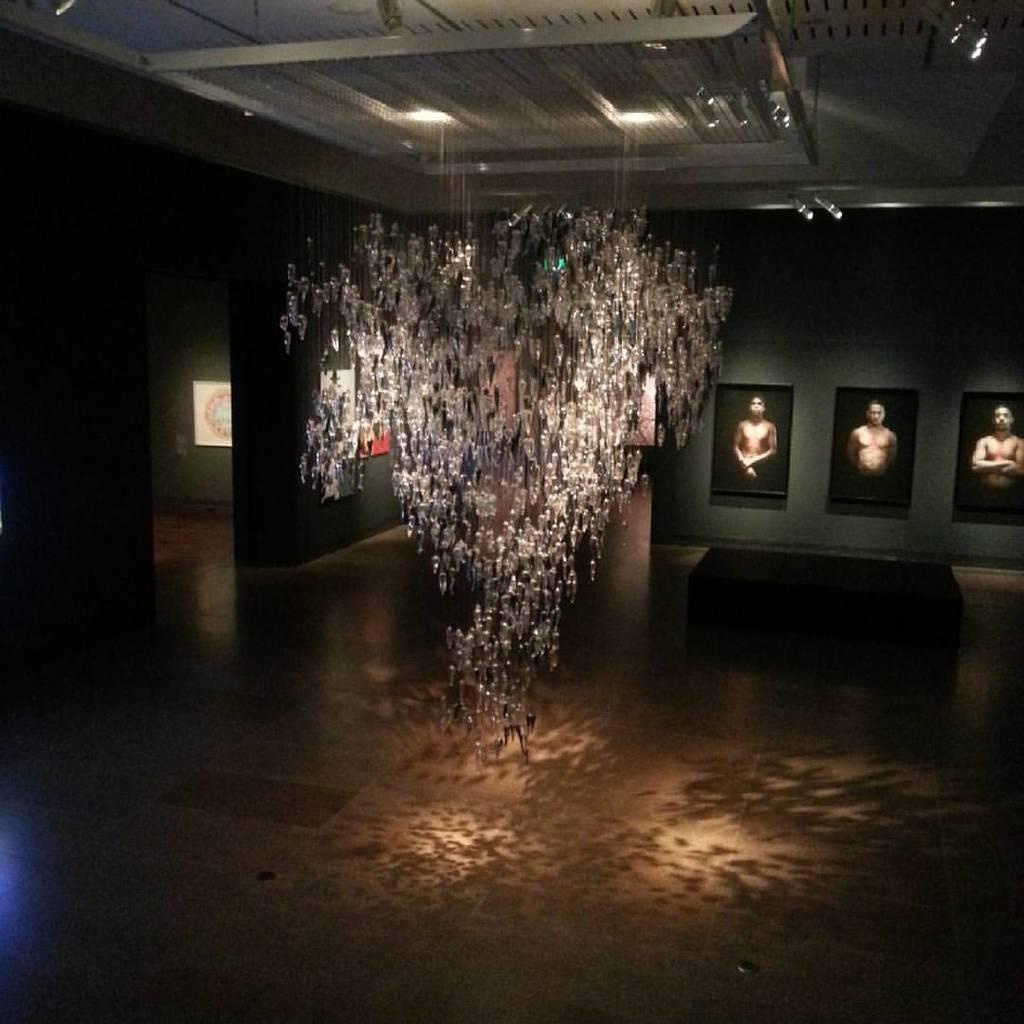In one or two sentences, can you explain what this image depicts? In this image few picture frames are attached to the wall. A lamp is hanged from the roof. 